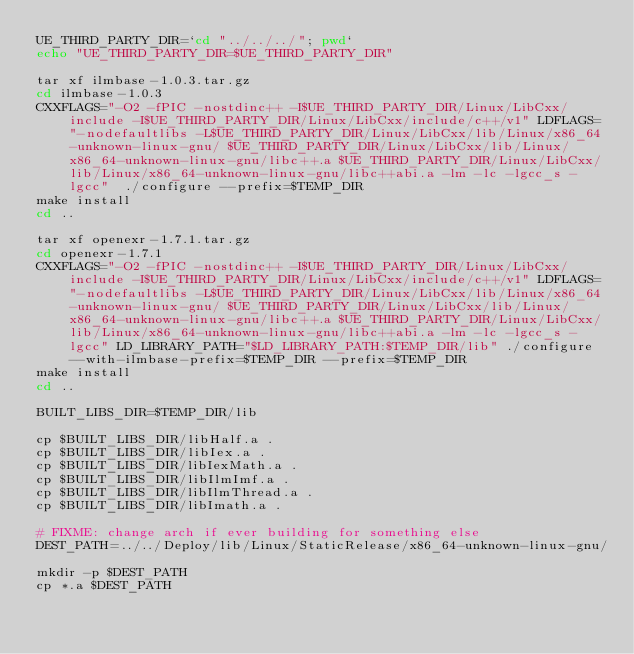<code> <loc_0><loc_0><loc_500><loc_500><_Bash_>UE_THIRD_PARTY_DIR=`cd "../../../"; pwd`
echo "UE_THIRD_PARTY_DIR=$UE_THIRD_PARTY_DIR"

tar xf ilmbase-1.0.3.tar.gz
cd ilmbase-1.0.3
CXXFLAGS="-O2 -fPIC -nostdinc++ -I$UE_THIRD_PARTY_DIR/Linux/LibCxx/include -I$UE_THIRD_PARTY_DIR/Linux/LibCxx/include/c++/v1" LDFLAGS="-nodefaultlibs -L$UE_THIRD_PARTY_DIR/Linux/LibCxx/lib/Linux/x86_64-unknown-linux-gnu/ $UE_THIRD_PARTY_DIR/Linux/LibCxx/lib/Linux/x86_64-unknown-linux-gnu/libc++.a $UE_THIRD_PARTY_DIR/Linux/LibCxx/lib/Linux/x86_64-unknown-linux-gnu/libc++abi.a -lm -lc -lgcc_s -lgcc"  ./configure --prefix=$TEMP_DIR
make install
cd ..

tar xf openexr-1.7.1.tar.gz
cd openexr-1.7.1
CXXFLAGS="-O2 -fPIC -nostdinc++ -I$UE_THIRD_PARTY_DIR/Linux/LibCxx/include -I$UE_THIRD_PARTY_DIR/Linux/LibCxx/include/c++/v1" LDFLAGS="-nodefaultlibs -L$UE_THIRD_PARTY_DIR/Linux/LibCxx/lib/Linux/x86_64-unknown-linux-gnu/ $UE_THIRD_PARTY_DIR/Linux/LibCxx/lib/Linux/x86_64-unknown-linux-gnu/libc++.a $UE_THIRD_PARTY_DIR/Linux/LibCxx/lib/Linux/x86_64-unknown-linux-gnu/libc++abi.a -lm -lc -lgcc_s -lgcc" LD_LIBRARY_PATH="$LD_LIBRARY_PATH:$TEMP_DIR/lib" ./configure --with-ilmbase-prefix=$TEMP_DIR --prefix=$TEMP_DIR
make install
cd ..

BUILT_LIBS_DIR=$TEMP_DIR/lib

cp $BUILT_LIBS_DIR/libHalf.a .
cp $BUILT_LIBS_DIR/libIex.a .
cp $BUILT_LIBS_DIR/libIexMath.a .
cp $BUILT_LIBS_DIR/libIlmImf.a .
cp $BUILT_LIBS_DIR/libIlmThread.a .
cp $BUILT_LIBS_DIR/libImath.a .

# FIXME: change arch if ever building for something else
DEST_PATH=../../Deploy/lib/Linux/StaticRelease/x86_64-unknown-linux-gnu/

mkdir -p $DEST_PATH
cp *.a $DEST_PATH
</code> 